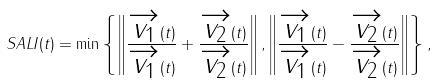<formula> <loc_0><loc_0><loc_500><loc_500>S A L I ( t ) = \min \left \{ \left \| \frac { \overrightarrow { v _ { 1 } } ( t ) } { \| \overrightarrow { v _ { 1 } } ( t ) \| } + \frac { \overrightarrow { v _ { 2 } } ( t ) } { \| \overrightarrow { v _ { 2 } } ( t ) \| } \right \| , \left \| \frac { \overrightarrow { v _ { 1 } } ( t ) } { \| \overrightarrow { v _ { 1 } } ( t ) \| } - \frac { \overrightarrow { v _ { 2 } } ( t ) } { \| \overrightarrow { v _ { 2 } } ( t ) \| } \right \| \right \} ,</formula> 